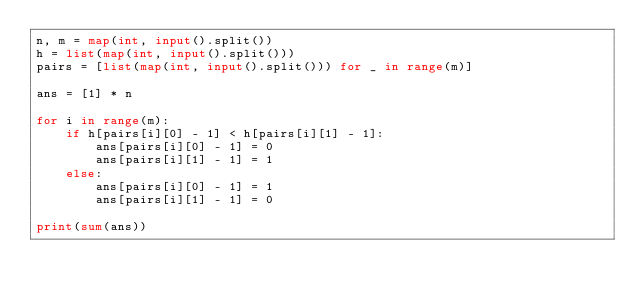<code> <loc_0><loc_0><loc_500><loc_500><_Python_>n, m = map(int, input().split())
h = list(map(int, input().split()))
pairs = [list(map(int, input().split())) for _ in range(m)]

ans = [1] * n

for i in range(m):
    if h[pairs[i][0] - 1] < h[pairs[i][1] - 1]:
        ans[pairs[i][0] - 1] = 0
        ans[pairs[i][1] - 1] = 1
    else:
        ans[pairs[i][0] - 1] = 1
        ans[pairs[i][1] - 1] = 0      

print(sum(ans))</code> 